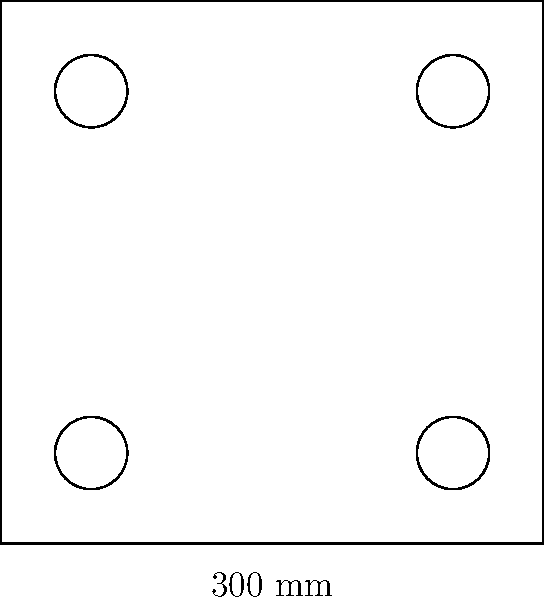Design a square reinforced concrete column with dimensions 300 mm x 300 mm to support an ultimate axial load ($P_u$) of 2000 kN. The column has 4 symmetrically placed longitudinal reinforcement bars. Determine the required area of steel reinforcement ($A_st$) if the concrete strength ($f'_c$) is 30 MPa and the yield strength of steel ($f_y$) is 420 MPa. Assume that the gross area of the column ($A_g$) is used in calculations and that the column is short and not subjected to any moment. To solve this problem, we'll follow these steps:

1) First, recall the equation for the axial capacity of a short reinforced concrete column:

   $$P_n = 0.85f'_c(A_g - A_{st}) + f_yA_{st}$$

2) We know that $P_u = \phi P_n$, where $\phi = 0.65$ for tied columns. So:

   $$P_u = 0.65[0.85f'_c(A_g - A_{st}) + f_yA_{st}]$$

3) Substitute the known values:
   $P_u = 2000$ kN = 2,000,000 N
   $f'_c = 30$ MPa = 30 N/mm²
   $f_y = 420$ MPa = 420 N/mm²
   $A_g = 300 \times 300 = 90,000$ mm²

4) Plug these into the equation:

   $$2,000,000 = 0.65[0.85 \times 30(90,000 - A_{st}) + 420A_{st}]$$

5) Simplify:

   $$2,000,000 = 0.65[2,295,000 - 25.5A_{st} + 420A_{st}]$$
   $$2,000,000 = 1,491,750 - 16.575A_{st} + 273A_{st}$$
   $$2,000,000 = 1,491,750 + 256.425A_{st}$$

6) Solve for $A_{st}$:

   $$508,250 = 256.425A_{st}$$
   $$A_{st} = 1,982 \text{ mm²}$$

7) Round up to the nearest practical size. The closest standard rebar size that provides this area would be 4 #8 bars (4 x 510 mm² = 2,040 mm²).
Answer: $A_{st} = 2,040 \text{ mm²}$ (4 #8 bars) 